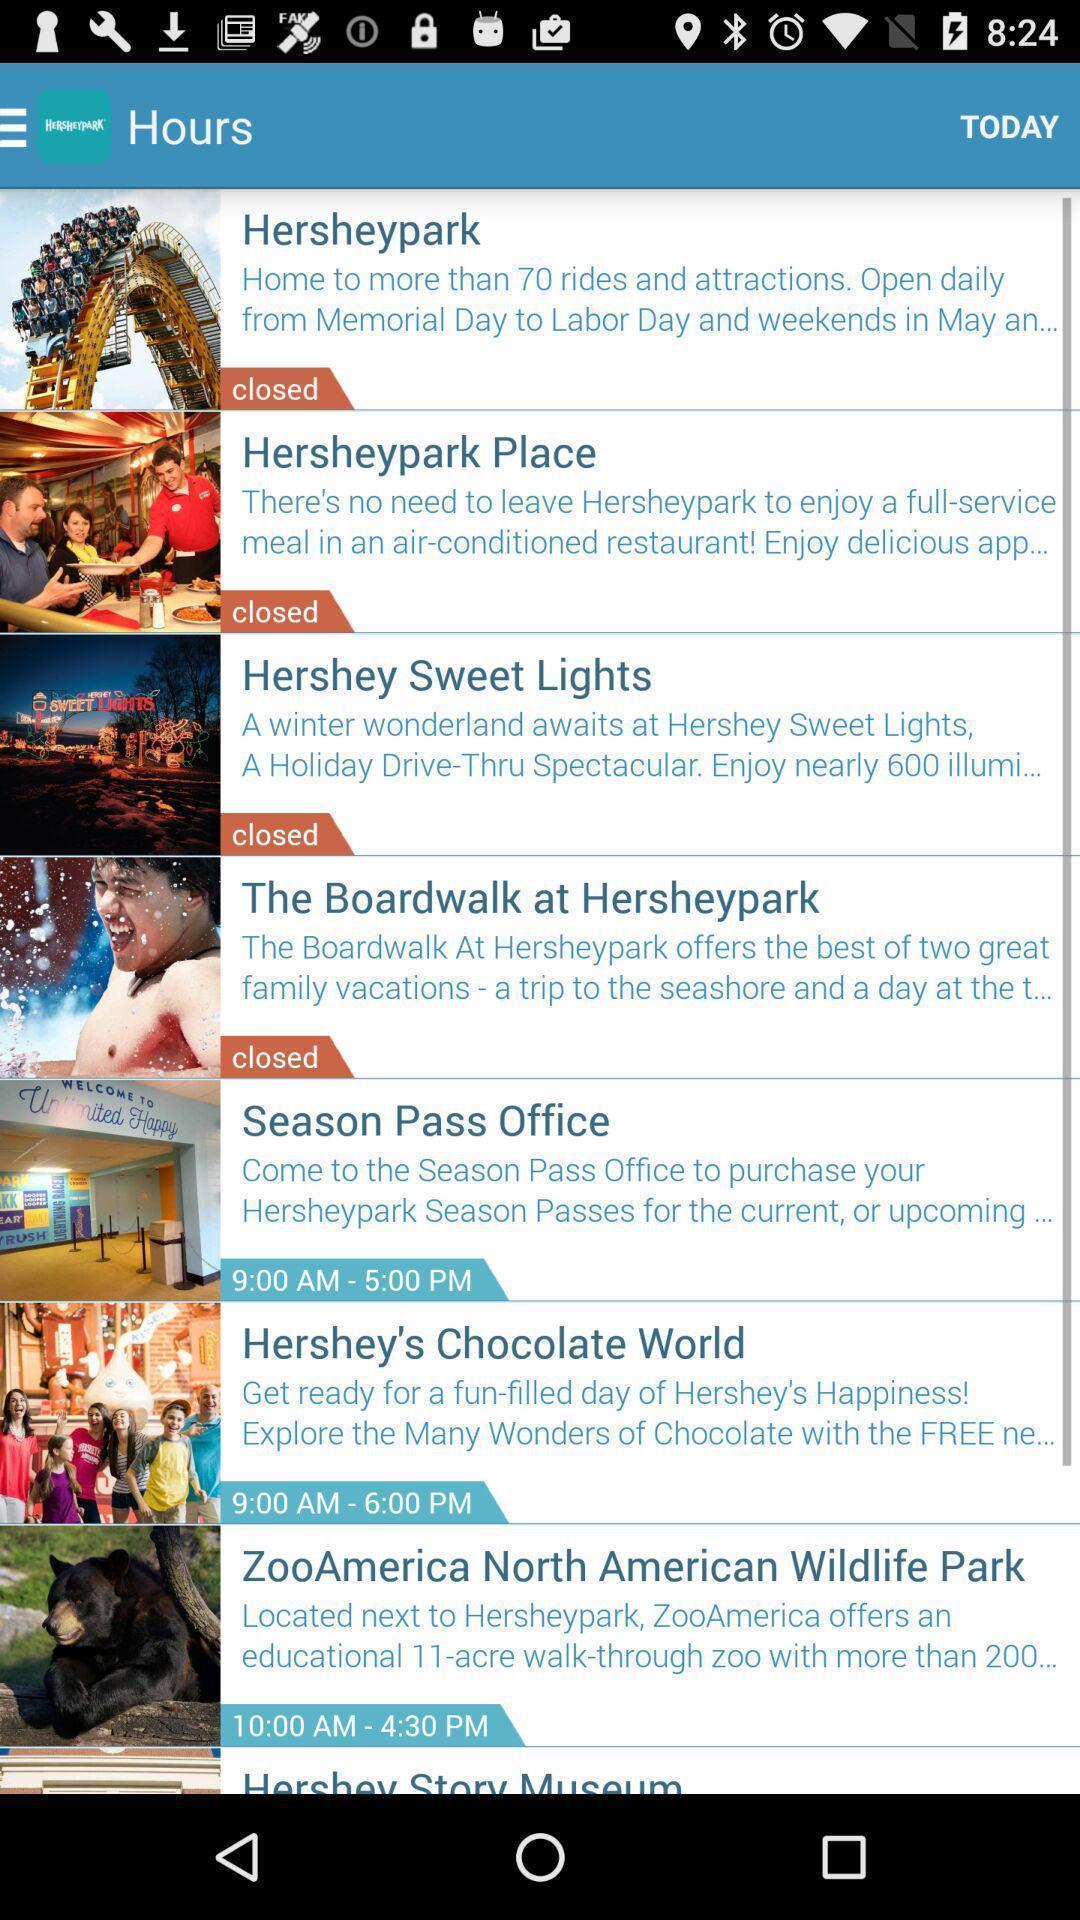Explain the elements present in this screenshot. Screen displaying hours. 